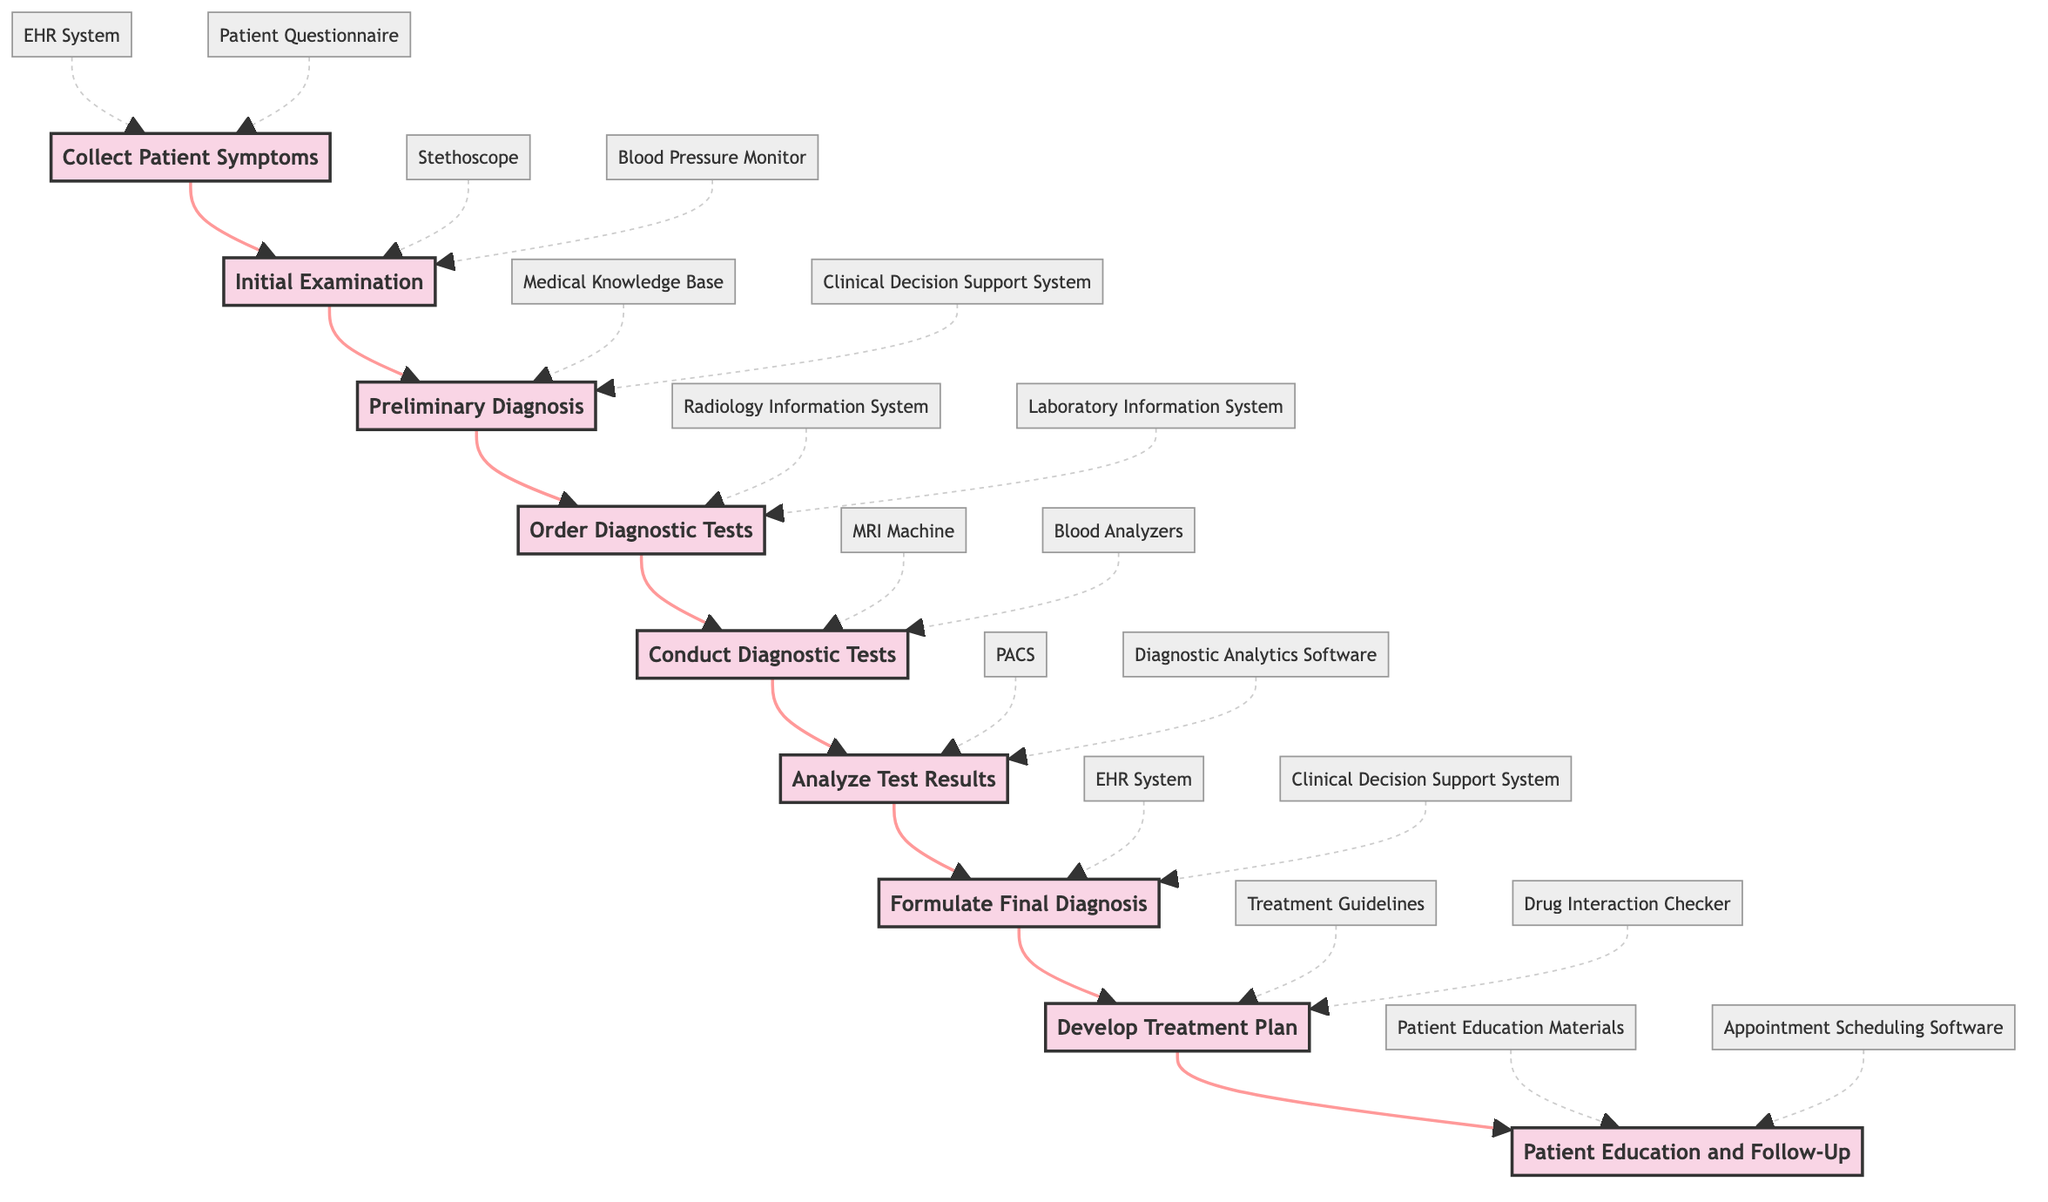What is the first step in the workflow? The first step shown in the diagram is "Collect Patient Symptoms," which initiates the diagnostic process by gathering information from the patient.
Answer: Collect Patient Symptoms How many steps are there in the workflow? By counting the distinct steps outlined in the diagram, there are a total of nine steps in the workflow.
Answer: 9 What diagnostic tools are used in the "Conduct Diagnostic Tests" step? In the "Conduct Diagnostic Tests" step, the tools listed are "MRI Machine" and "Blood Analyzers," which are used for performing the diagnostic tests.
Answer: MRI Machine, Blood Analyzers Which step follows "Analyze Test Results"? After analyzing the test results, the next step in the workflow is "Formulate Final Diagnosis," where the clinician combines findings to make a diagnosis.
Answer: Formulate Final Diagnosis What type of system is utilized during both the "Formulate Final Diagnosis" and "Develop Treatment Plan" steps? Both steps use the "Clinical Decision Support System" to assist in the decision-making process related to diagnosis and treatment.
Answer: Clinical Decision Support System Which step can lead directly to "Patient Education and Follow-Up"? The step "Develop Treatment Plan" leads directly to "Patient Education and Follow-Up," as it involves informing the patient about their treatment plan.
Answer: Develop Treatment Plan How does the "Order Diagnostic Tests" step connect to the "Conduct Diagnostic Tests" step? The "Order Diagnostic Tests" step leads directly to "Conduct Diagnostic Tests," indicating that ordering tests is necessary before conducting them.
Answer: Directly In which step are preliminary hypotheses formulated? Preliminary hypotheses are formulated in the "Preliminary Diagnosis" step based on symptoms and findings from the initial examination.
Answer: Preliminary Diagnosis Which tools are associated with gathering patient-reported symptoms? The tools associated with gathering patient-reported symptoms are "EHR System" and "Patient Questionnaire," as they facilitate the collection of information.
Answer: EHR System, Patient Questionnaire 